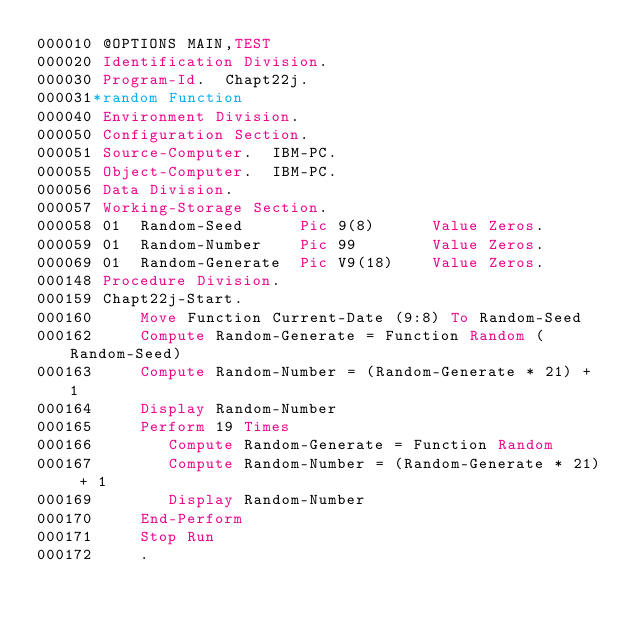Convert code to text. <code><loc_0><loc_0><loc_500><loc_500><_COBOL_>000010 @OPTIONS MAIN,TEST
000020 Identification Division.
000030 Program-Id.  Chapt22j.
000031*random Function
000040 Environment Division.
000050 Configuration Section.
000051 Source-Computer.  IBM-PC.
000055 Object-Computer.  IBM-PC.
000056 Data Division.
000057 Working-Storage Section.
000058 01  Random-Seed      Pic 9(8)      Value Zeros.
000059 01  Random-Number    Pic 99        Value Zeros.
000069 01  Random-Generate  Pic V9(18)    Value Zeros.
000148 Procedure Division.
000159 Chapt22j-Start.
000160     Move Function Current-Date (9:8) To Random-Seed
000162     Compute Random-Generate = Function Random (Random-Seed)
000163     Compute Random-Number = (Random-Generate * 21) + 1
000164     Display Random-Number
000165     Perform 19 Times
000166        Compute Random-Generate = Function Random
000167        Compute Random-Number = (Random-Generate * 21) + 1
000169        Display Random-Number
000170     End-Perform
000171     Stop Run
000172     .</code> 